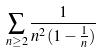<formula> <loc_0><loc_0><loc_500><loc_500>\sum _ { n \geq 2 } \frac { 1 } { n ^ { 2 } ( 1 - \frac { 1 } { n } ) }</formula> 